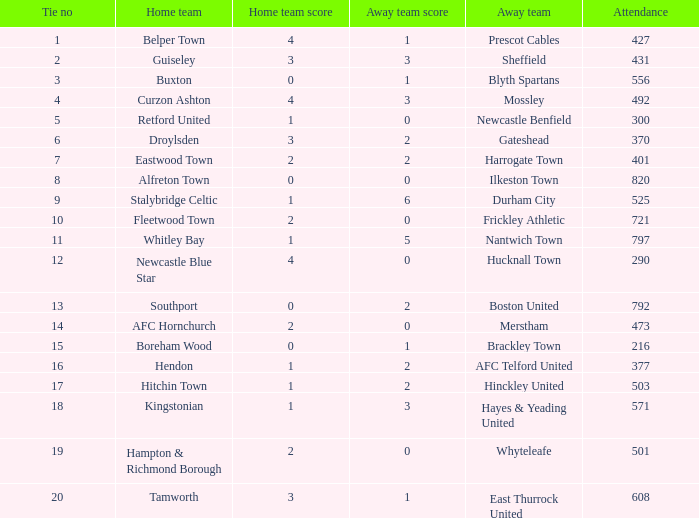What was the score for home team AFC Hornchurch? 2–0. 